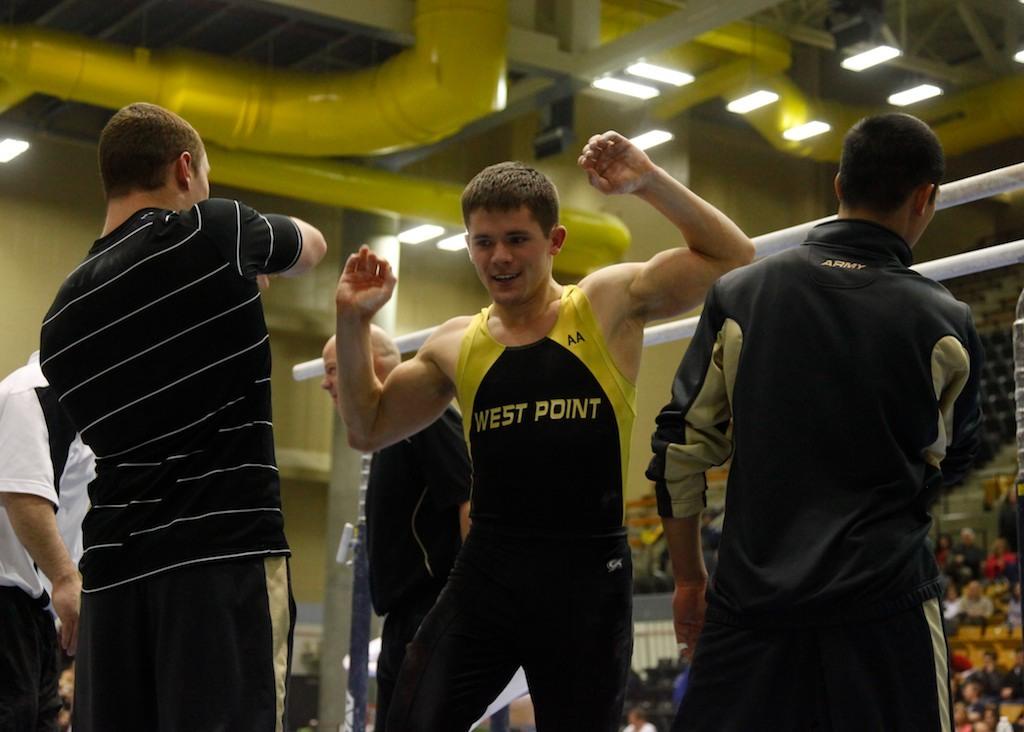What does the text in the yellow box say?
Your answer should be compact. West point. What is written on the persons shirt?
Provide a succinct answer. West point. 